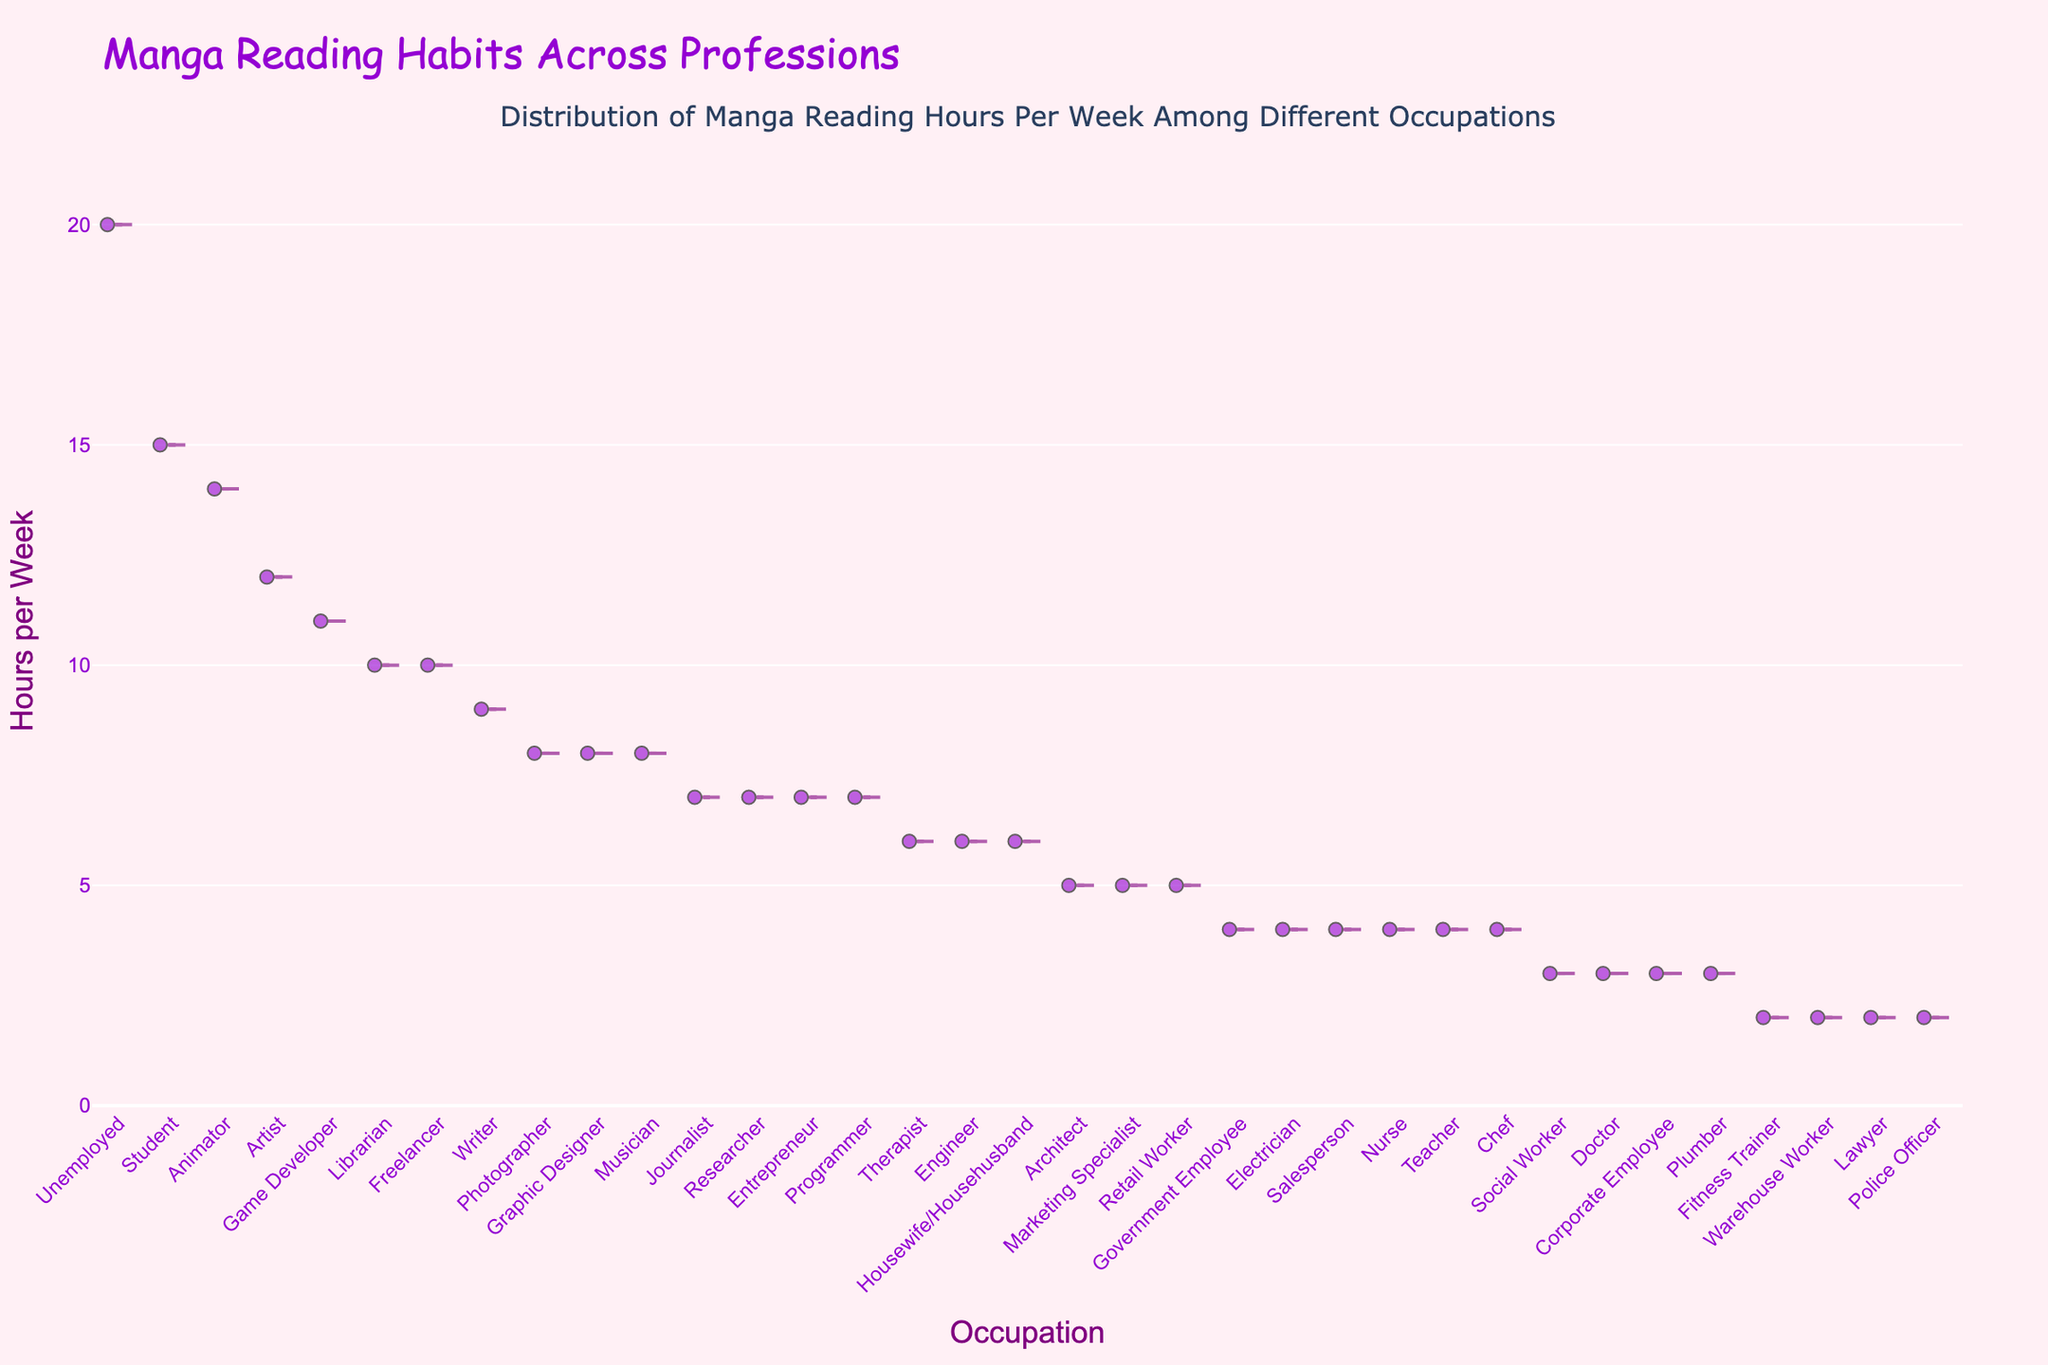What's the title of the figure? The title is usually located at the top center of the figure. In this case, the title is displayed in a font size of 24 and reads "Manga Reading Habits Across Professions."
Answer: Manga Reading Habits Across Professions What is the range of hours per week shown on the y-axis? The y-axis range is determined by looking at the lowest and highest values indicated on the vertical axis. Here, it starts from 0 and goes up to max value + 2, which is 22 hours per week.
Answer: 0 to 22 Which occupation reads the most manga on average per week? By examining the points along the y-axis for each occupation, and noting the highest average hours, we can see that 'Unemployed' reads the most manga per week.
Answer: Unemployed What is the median manga reading hours per week for 'Student'? To determine the median, we look at the violin plot's horizontal line inside the box display for 'Student'. The median is where this line is positioned.
Answer: 15 hours Are there occupations that have the same manga reading hours per week? By looking at the placements of points along the y-axis for different occupations, we can see that occupations like 'Nurse', 'Electrician', 'Teacher', etc., all have the same value.
Answer: Yes How many occupations read 10 or more hours of manga per week? We see which occupations have data points above the 10-hour mark on the y-axis. Counting these, there are 'Freelancer', 'Game Developer', 'Animator', 'Librarian', 'Artist', and 'Unemployed'.
Answer: 6 What’s the median manga reading hours per week for occupations reading less than 5 hours? The median requires ordering the hours and finding the middle value. Occupations reading less than 5 hours include Electrician, Chef, Fitness Trainer, Lawyer, Police Officer, and Corporate Employee. Their hours are (4, 4, 4, 4, 2, 2), hence the median is (4+4)/2.
Answer: 4 hours Which occupation reads the least manga per week, and how much? By checking the lowest point on the y-axis for any occupations, 'Police Officer', 'Fitness Trainer', and 'Lawyer' read the least at 2 hours.
Answer: Police Officer, 2 hours How many hours more does 'Unemployed' read manga compared to 'Teacher'? By comparing the two y-values for 'Unemployed' and 'Teacher', 'Unemployed' reads 20 hours, and 'Teacher' reads 4 hours, subtracting these gives 20 - 4 = 16 hours more.
Answer: 16 hours Which occupation has greater manga reading hours, 'Programmer' or 'Teacher'? Checking the y-axis for both 'Programmer' and 'Teacher', Programmer has a value of 7, and Teachers have a value of 4.
Answer: Programmer 